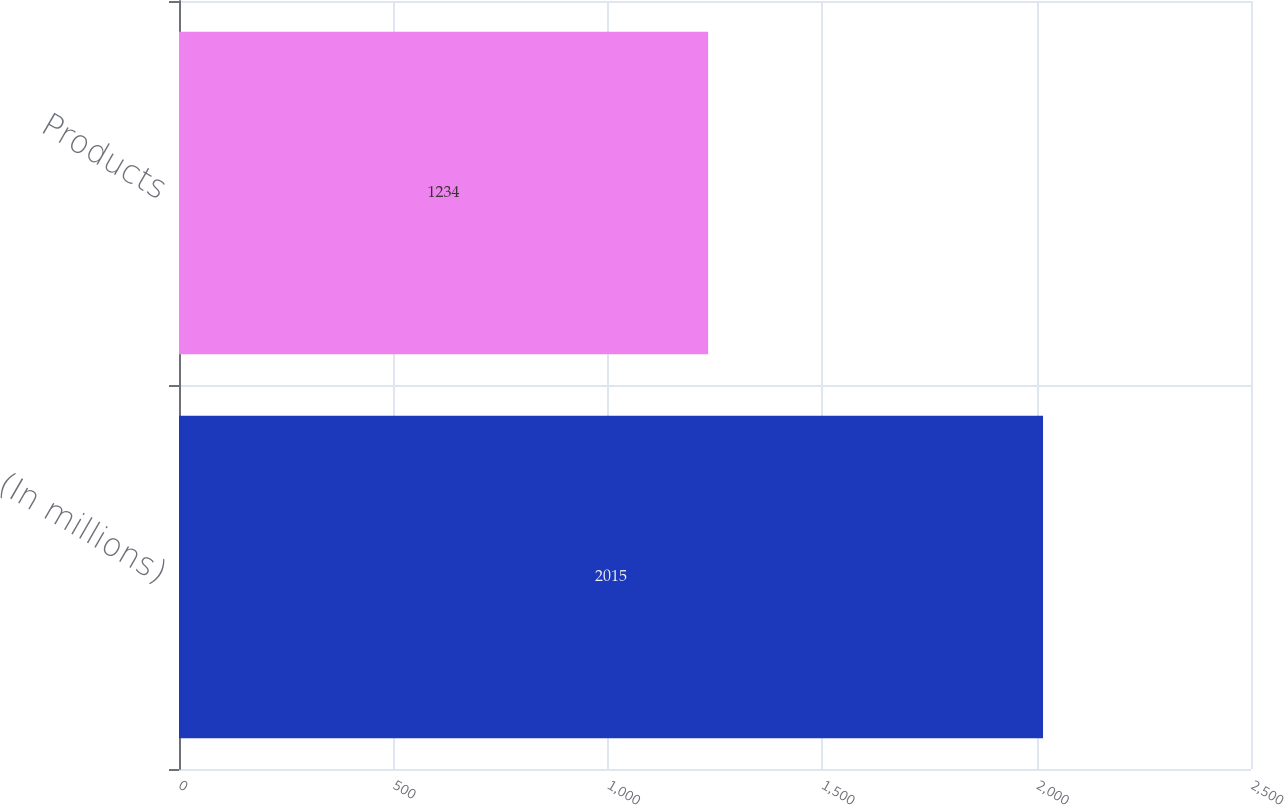<chart> <loc_0><loc_0><loc_500><loc_500><bar_chart><fcel>(In millions)<fcel>Products<nl><fcel>2015<fcel>1234<nl></chart> 